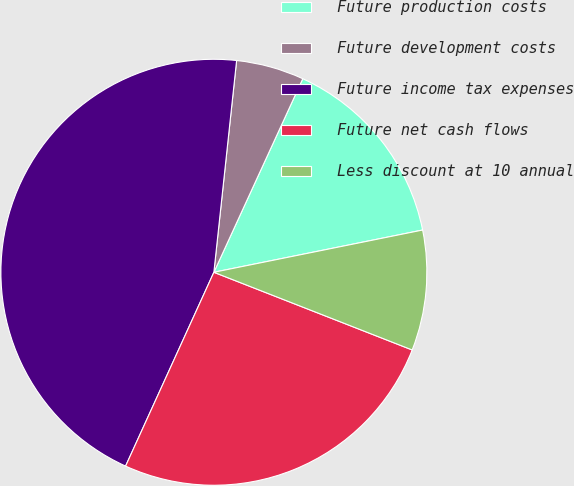<chart> <loc_0><loc_0><loc_500><loc_500><pie_chart><fcel>Future production costs<fcel>Future development costs<fcel>Future income tax expenses<fcel>Future net cash flows<fcel>Less discount at 10 annual<nl><fcel>14.97%<fcel>5.15%<fcel>44.9%<fcel>25.86%<fcel>9.12%<nl></chart> 